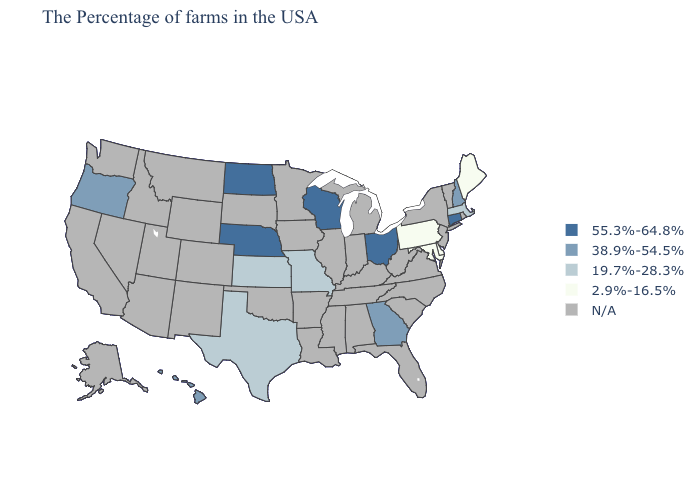Name the states that have a value in the range 55.3%-64.8%?
Answer briefly. Connecticut, Ohio, Wisconsin, Nebraska, North Dakota. Name the states that have a value in the range 55.3%-64.8%?
Give a very brief answer. Connecticut, Ohio, Wisconsin, Nebraska, North Dakota. What is the highest value in the West ?
Write a very short answer. 38.9%-54.5%. What is the value of Alabama?
Keep it brief. N/A. What is the value of Rhode Island?
Be succinct. N/A. Which states have the lowest value in the USA?
Give a very brief answer. Maine, Delaware, Maryland, Pennsylvania. What is the value of Colorado?
Keep it brief. N/A. What is the value of New Mexico?
Concise answer only. N/A. Does the first symbol in the legend represent the smallest category?
Give a very brief answer. No. What is the highest value in states that border Pennsylvania?
Give a very brief answer. 55.3%-64.8%. What is the highest value in the USA?
Be succinct. 55.3%-64.8%. What is the value of Arizona?
Short answer required. N/A. Among the states that border Oklahoma , which have the highest value?
Quick response, please. Missouri, Kansas, Texas. 